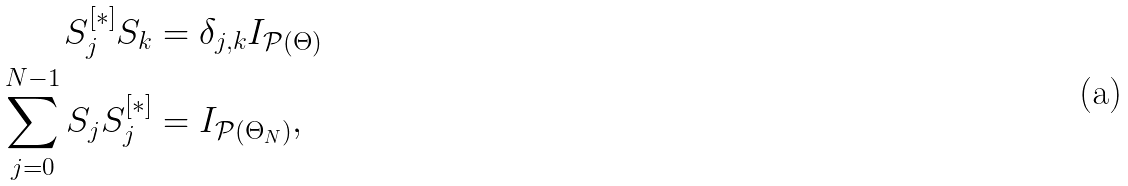Convert formula to latex. <formula><loc_0><loc_0><loc_500><loc_500>S _ { j } ^ { [ * ] } S _ { k } & = \delta _ { j , k } I _ { \mathcal { P } ( \Theta ) } \\ \sum _ { j = 0 } ^ { N - 1 } S _ { j } S _ { j } ^ { [ * ] } & = I _ { \mathcal { P } ( \Theta _ { N } ) } ,</formula> 